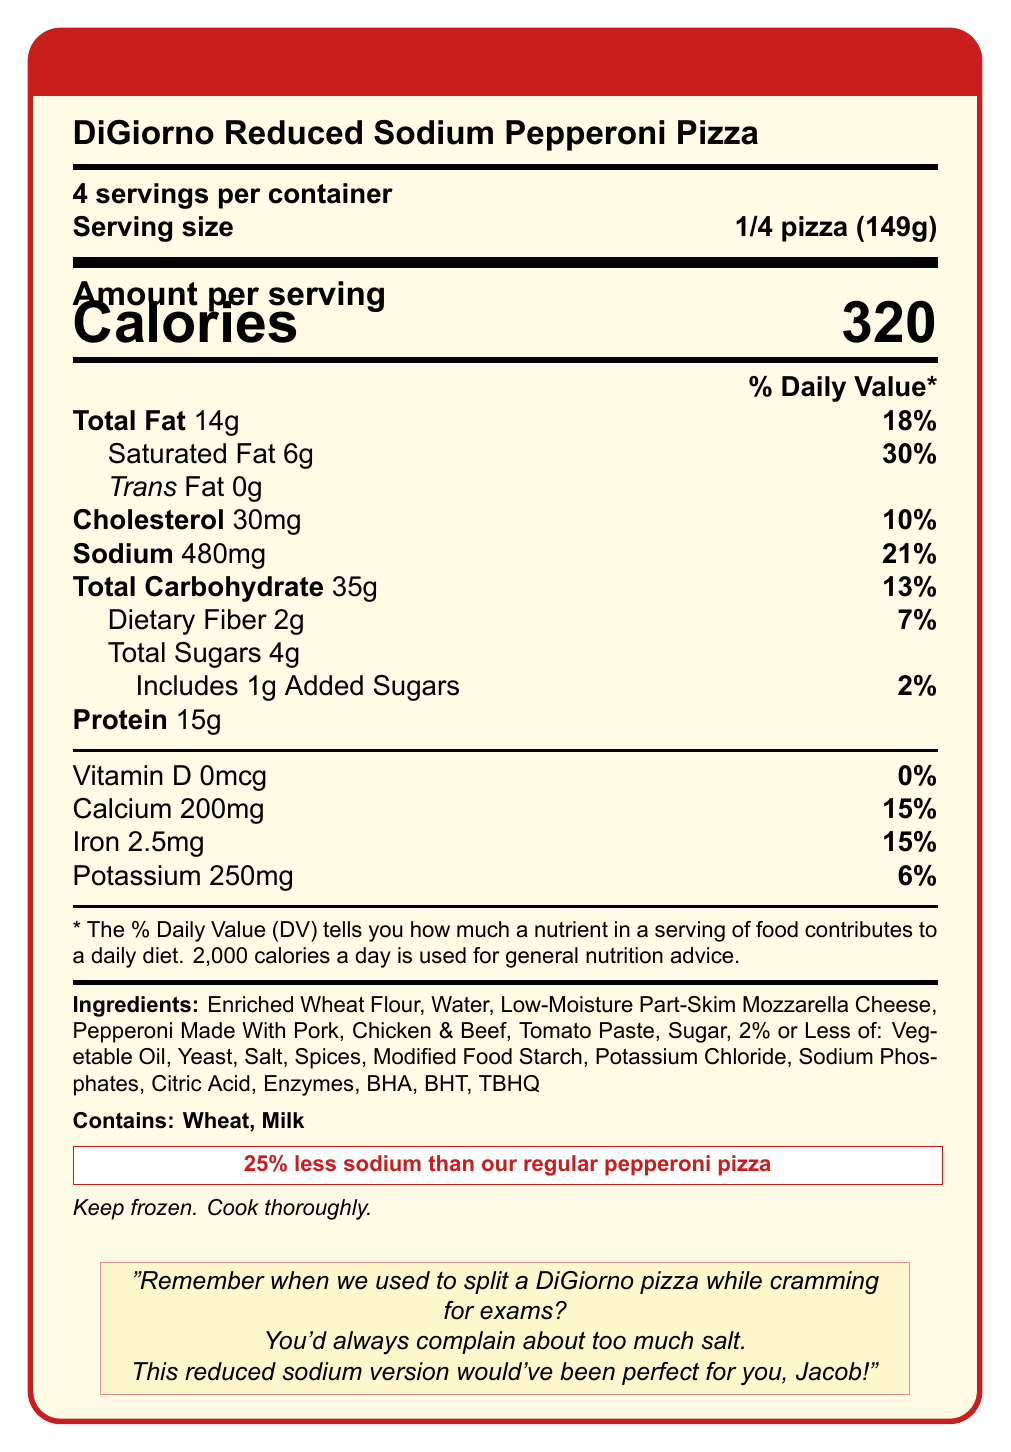what is the product name? The product name is listed at the beginning of the document.
Answer: DiGiorno Reduced Sodium Pepperoni Pizza what is the serving size? The serving size is specified as "1/4 pizza (149g)" under the product name and servings per container.
Answer: 1/4 pizza (149g) how many calories are there per serving? The document specifies that there are 320 calories per serving.
Answer: 320 what is the amount of total fat per serving? The amount of total fat per serving is listed as 14g in the nutrition facts.
Answer: 14g what are the two allergens mentioned? The allergens listed in the ingredients section are Wheat and Milk.
Answer: Wheat, Milk how much protein is in one serving? The protein content per serving is stated as 15g.
Answer: 15g what vitamin has 0% daily value? Vitamin D has a daily value of 0%, as indicated in the nutrition facts.
Answer: Vitamin D how many added sugars are in one serving? The document states that there is 1g of added sugars per serving.
Answer: 1g what is the total carbohydrate content per serving? The document states that the total carbohydrate content per serving is 35g.
Answer: 35g what is the main added benefit of this pizza compared to the regular version? The document claims that this pizza has "25% less sodium than our regular pepperoni pizza."
Answer: 25% less sodium how much calcium does one serving provide in terms of daily value percentage? The document indicates that one serving provides 15% of the daily value for calcium.
Answer: 15% which nutrient has the highest % daily value? A. Sodium B. Protein C. Saturated Fat D. Dietary Fiber Saturated Fat has the highest % daily value at 30%.
Answer: C. Saturated Fat how much potassium is in each serving? A. 250mg B. 200mg C. 30mg D. 100mg The document states that there are 250mg of potassium per serving.
Answer: A. 250mg does this product include Trans Fat? The document indicates that Trans Fat is 0g per serving.
Answer: No has this product really been part of your high school memories with Jacob? The document includes a personal note reminiscing about high school memories, but it does not confirm if the specific product was part of those memories.
Answer: Not enough information could Jacob have preferred this pizza over the regular version? Jacob might have preferred this reduced sodium version because the personal note mentions that he used to complain about too much salt.
Answer: Yes summarize the main points of the document. The document serves as a comprehensive guide on the nutritional composition of the Digiorno Reduced Sodium Pepperoni Pizza, its dietary benefits, and a personal connection to someone who would have liked its reduced sodium content.
Answer: The document provides nutritional information for the "DiGiorno Reduced Sodium Pepperoni Pizza", highlighting its reduced sodium content (25% less than the regular version). It details serving size, calories, and specific nutrient information, emphasizing both macronutrients and micronutrients. Allergens include wheat and milk. In addition, the document features a personal anecdote about Jacob, who would have preferred this lower-sodium option. The storage instructions recommend keeping it frozen and cooking it thoroughly. 